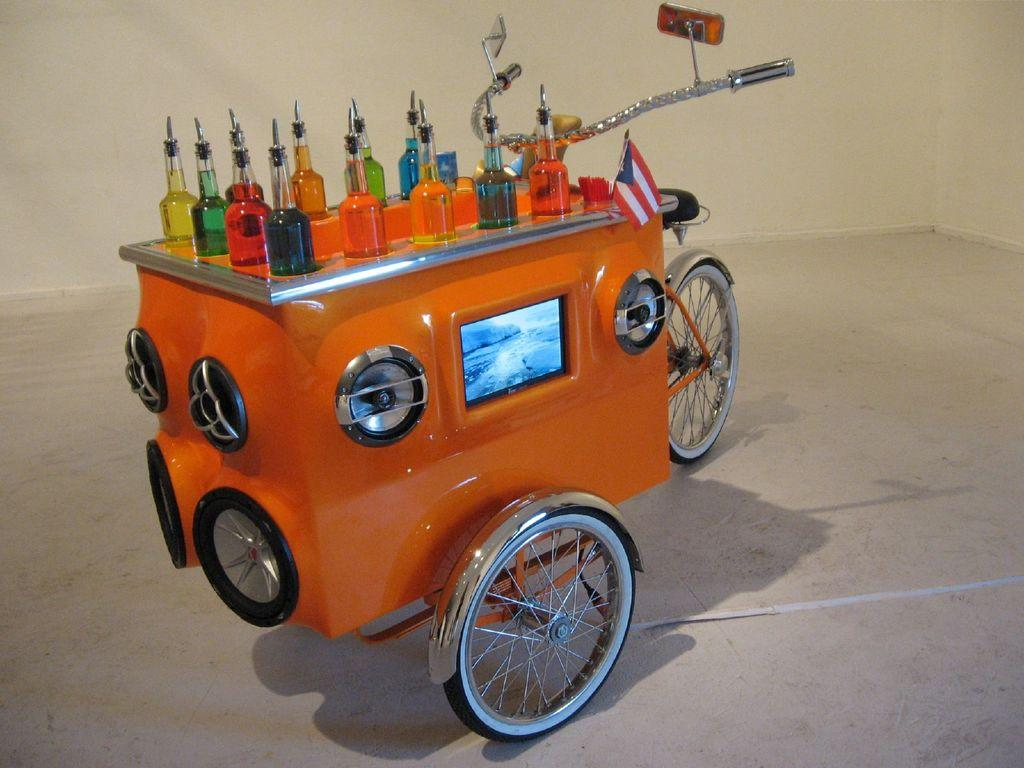What is the main object in the image? There is a cart with bottles in the image. What is inside the cart? The cart contains bottles. What type of surface is visible in the image? There is a floor visible in the image. What can be seen in the background of the image? There is a wall in the background of the image. How many snakes are slithering on the roof in the image? There are no snakes or roof present in the image. What is the digestive process of the bottles in the cart? Bottles do not have a digestive process, as they are inanimate objects. 